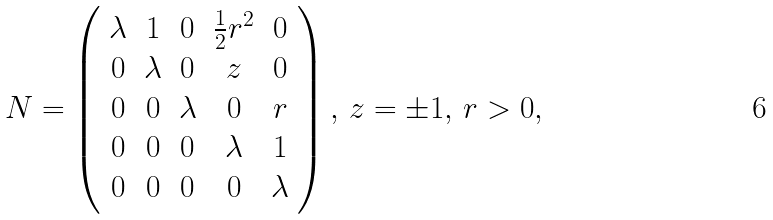<formula> <loc_0><loc_0><loc_500><loc_500>N = \left ( \begin{array} { c c c c c } \lambda & 1 & 0 & \frac { 1 } { 2 } r ^ { 2 } & 0 \\ 0 & \lambda & 0 & z & 0 \\ 0 & 0 & \lambda & 0 & r \\ 0 & 0 & 0 & \lambda & 1 \\ 0 & 0 & 0 & 0 & \lambda \end{array} \right ) , \, z = \pm 1 , \, r > 0 ,</formula> 